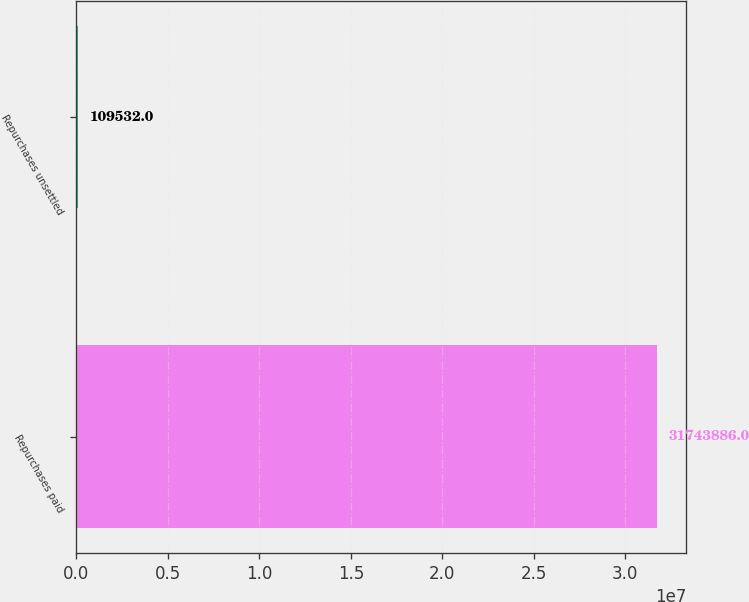Convert chart. <chart><loc_0><loc_0><loc_500><loc_500><bar_chart><fcel>Repurchases paid<fcel>Repurchases unsettled<nl><fcel>3.17439e+07<fcel>109532<nl></chart> 